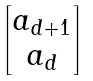Convert formula to latex. <formula><loc_0><loc_0><loc_500><loc_500>\begin{bmatrix} a _ { d + 1 } \\ a _ { d } \end{bmatrix}</formula> 